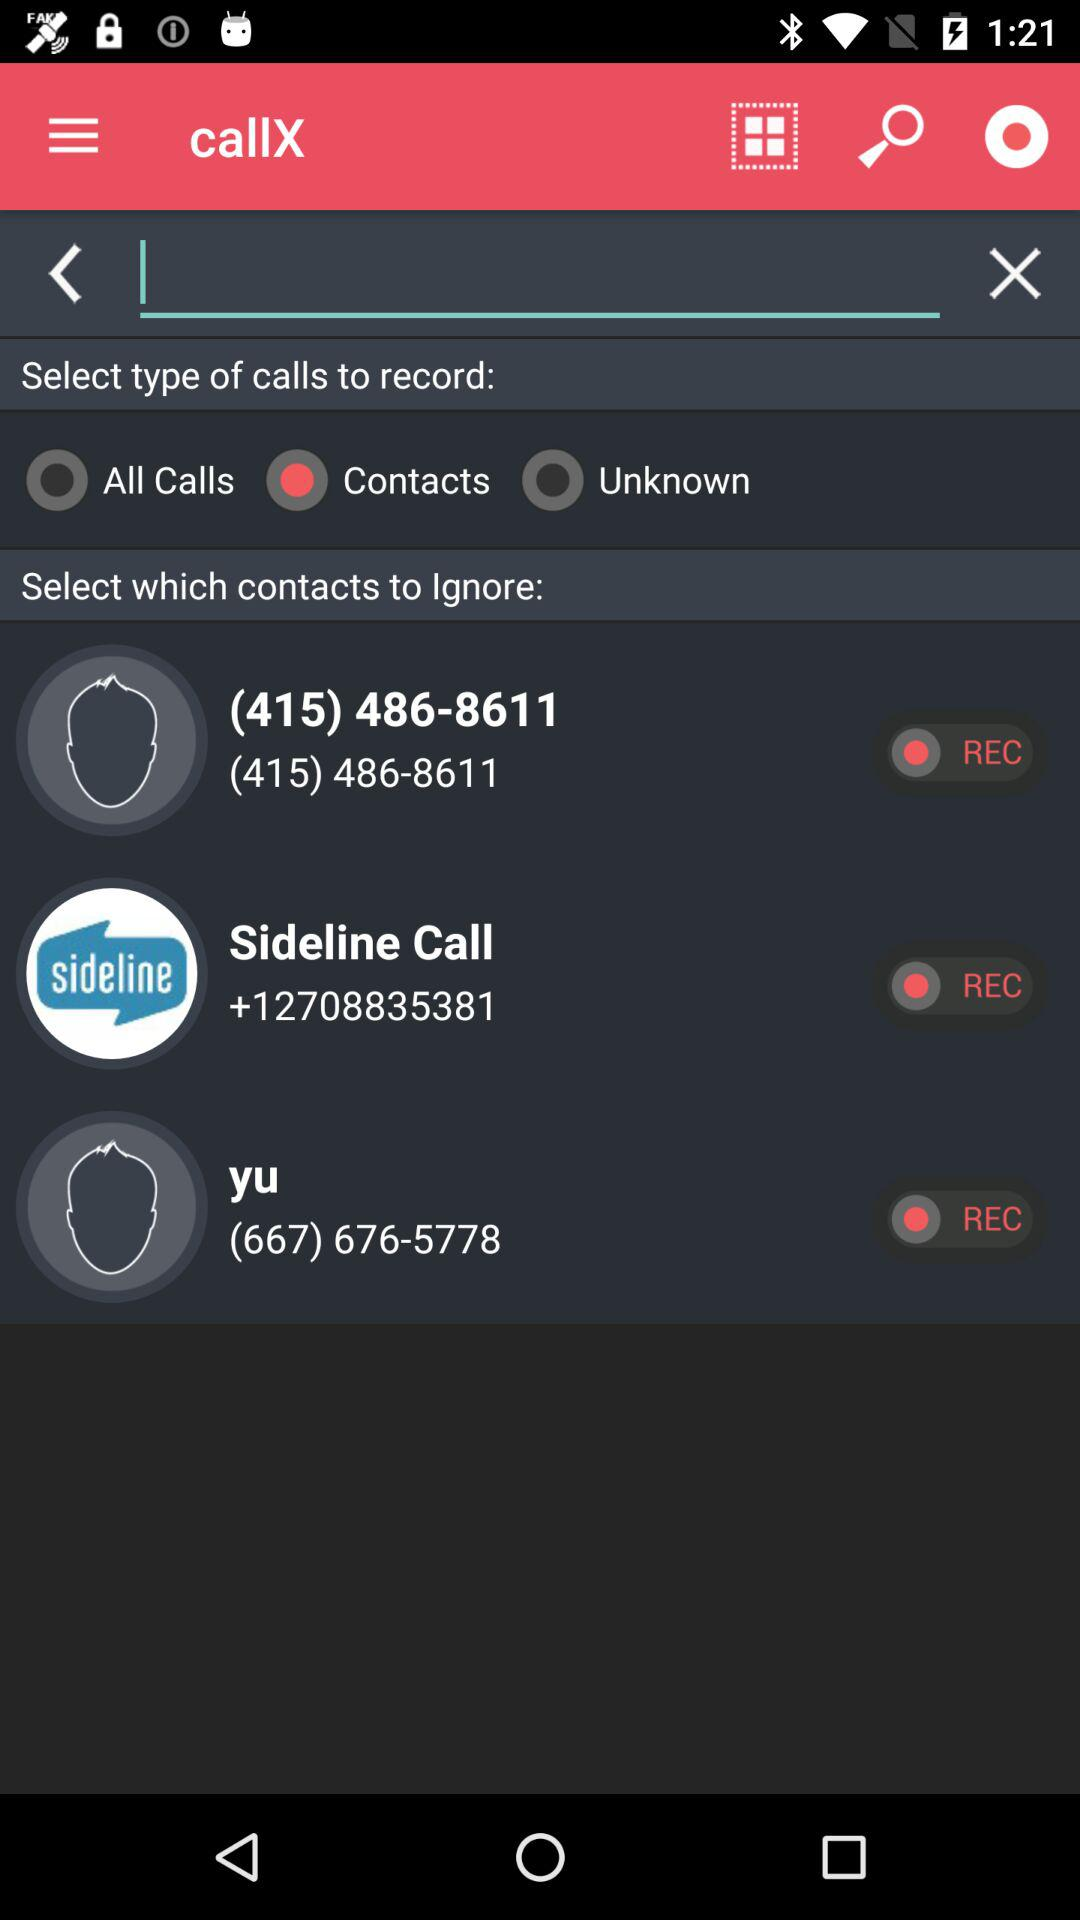What is the number of sideline call? The number is +12708835381. 